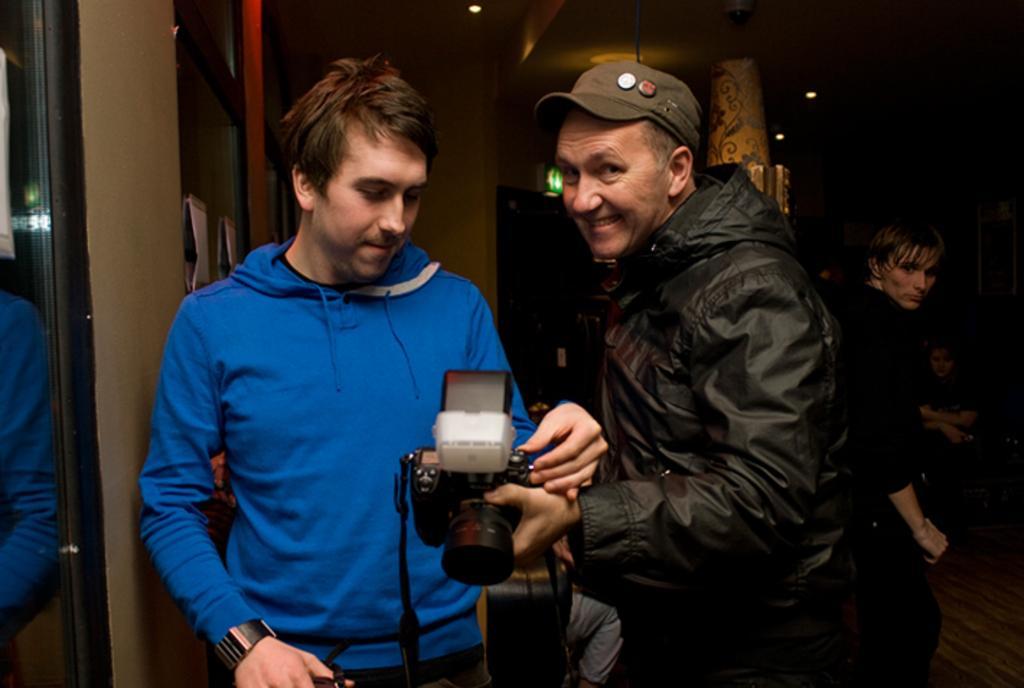Could you give a brief overview of what you see in this image? In this image we can see two people standing and holding cameras. And we can see one person wearing a cap. And we can see the mirror. And we can see the lights, and we can see some other people. 